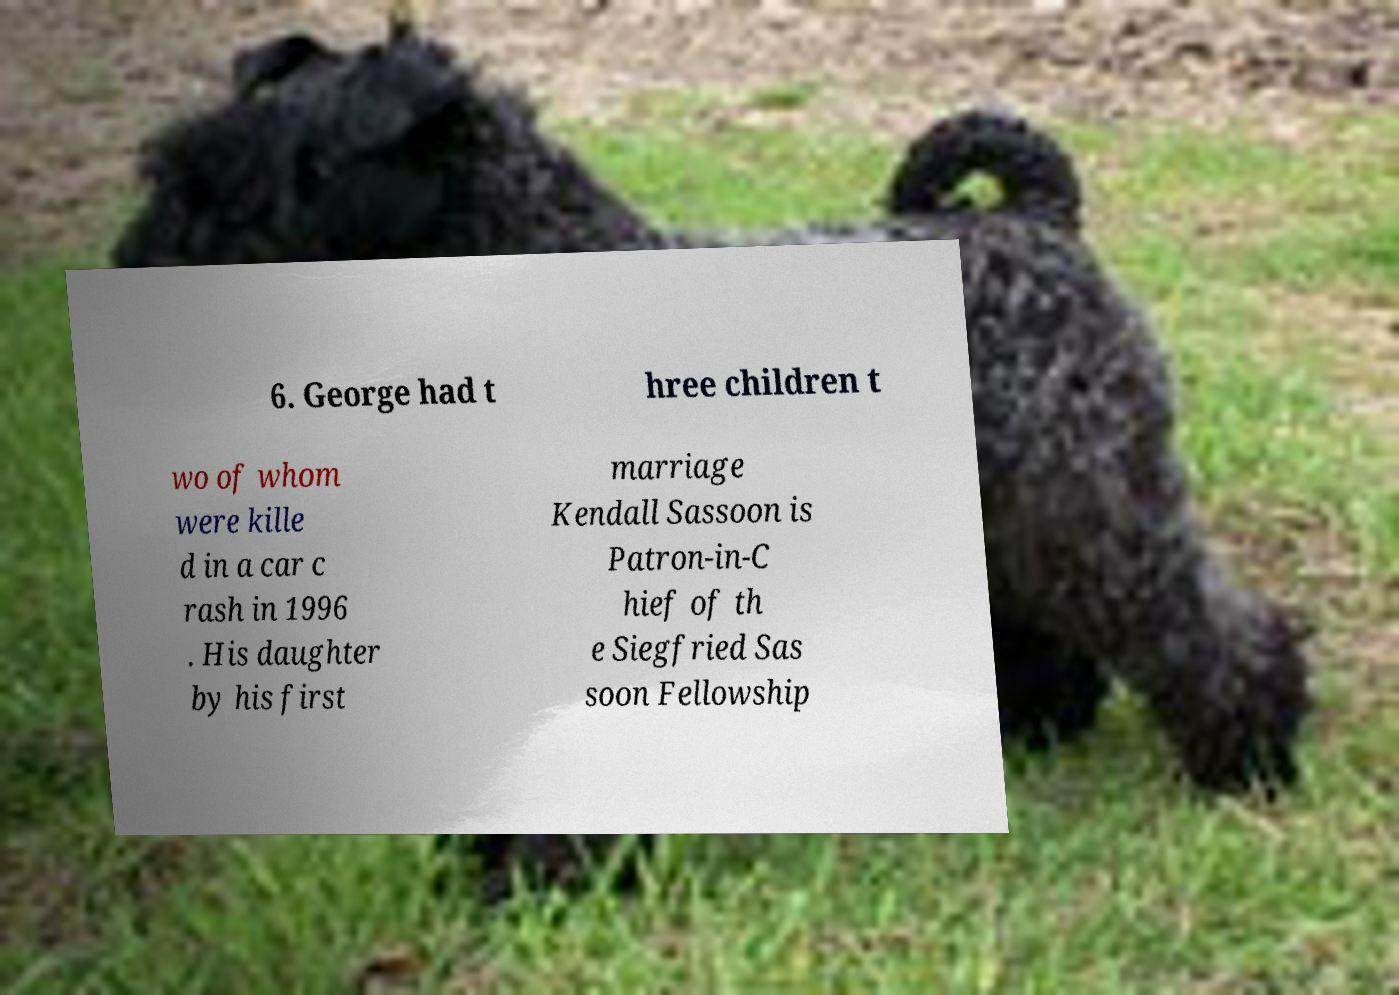Please identify and transcribe the text found in this image. 6. George had t hree children t wo of whom were kille d in a car c rash in 1996 . His daughter by his first marriage Kendall Sassoon is Patron-in-C hief of th e Siegfried Sas soon Fellowship 